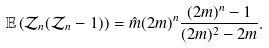<formula> <loc_0><loc_0><loc_500><loc_500>\mathbb { E } \left ( \mathcal { Z } _ { n } ( \mathcal { Z } _ { n } - 1 ) \right ) = \hat { m } ( 2 m ) ^ { n } \frac { ( 2 m ) ^ { n } - 1 } { ( 2 m ) ^ { 2 } - 2 m } .</formula> 